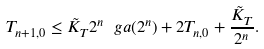<formula> <loc_0><loc_0><loc_500><loc_500>T _ { n + 1 , 0 } \leq \tilde { K } _ { T } 2 ^ { n } \ g a ( 2 ^ { n } ) + 2 T _ { n , 0 } + \frac { \tilde { K } _ { T } } { 2 ^ { n } } .</formula> 